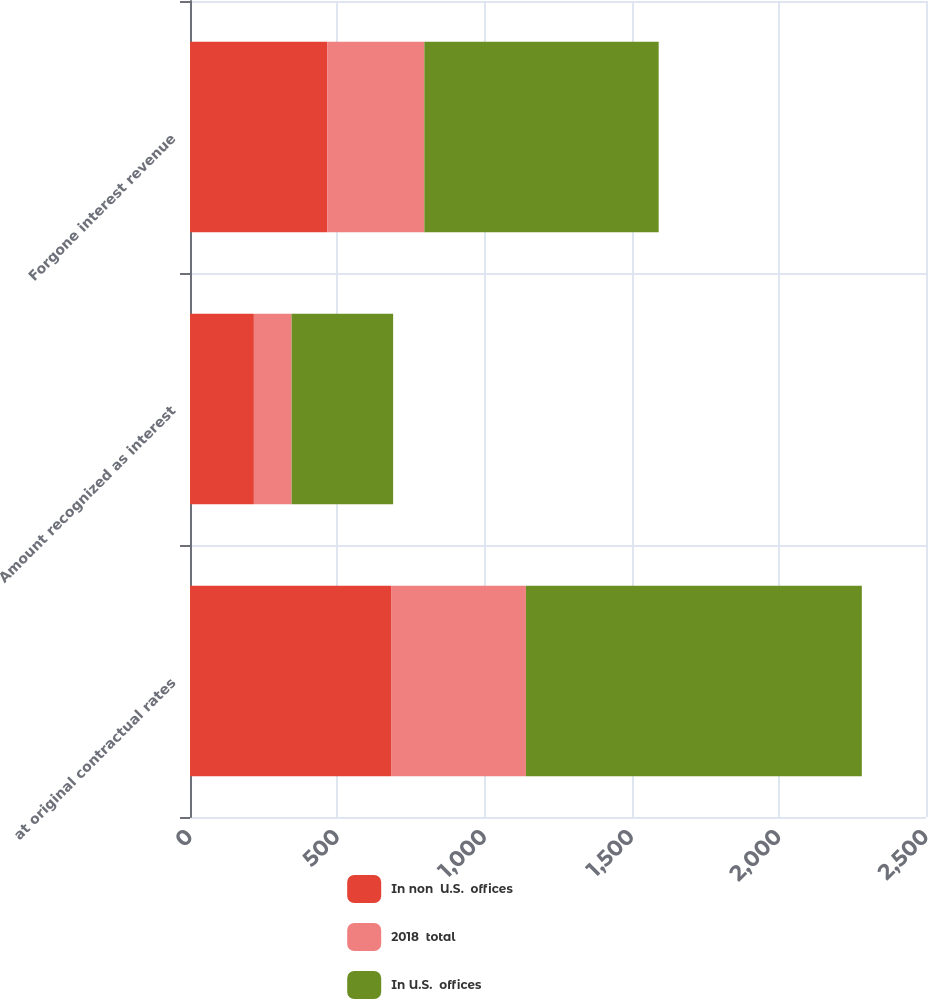Convert chart. <chart><loc_0><loc_0><loc_500><loc_500><stacked_bar_chart><ecel><fcel>at original contractual rates<fcel>Amount recognized as interest<fcel>Forgone interest revenue<nl><fcel>In non  U.S.  offices<fcel>683<fcel>217<fcel>466<nl><fcel>2018  total<fcel>458<fcel>128<fcel>330<nl><fcel>In U.S.  offices<fcel>1141<fcel>345<fcel>796<nl></chart> 